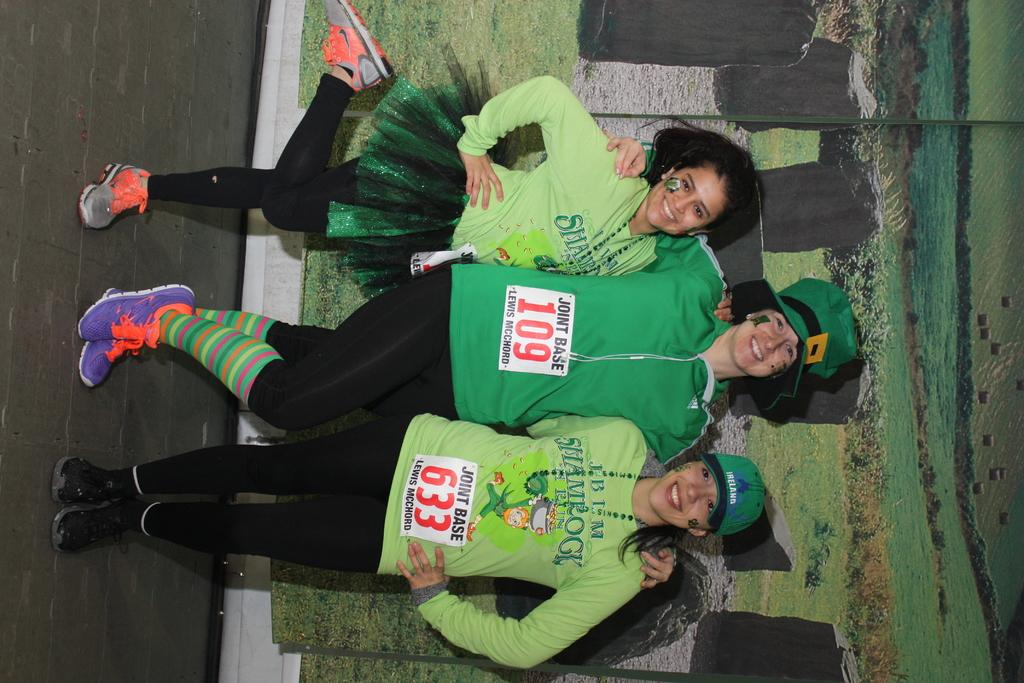How many people are in the image? There are three ladies in the image. Can you describe the attire of one of the ladies? One of the ladies is wearing a hat. What can be seen in the background of the image? There is a poster of a scenery in the background of the image. What type of bulb is used to light up the poster in the image? There is no bulb present in the image; it is a poster of a scenery in the background. How does the powder move around in the image? There is no powder present in the image. 